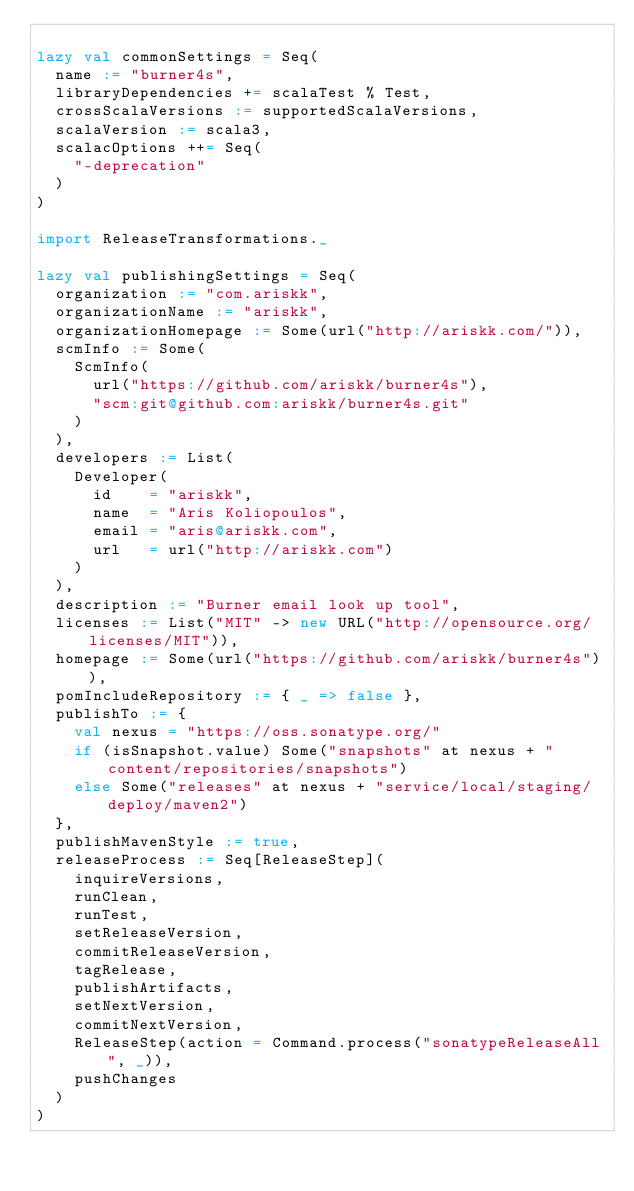<code> <loc_0><loc_0><loc_500><loc_500><_Scala_>
lazy val commonSettings = Seq(
  name := "burner4s",
  libraryDependencies += scalaTest % Test,
  crossScalaVersions := supportedScalaVersions,
  scalaVersion := scala3,
  scalacOptions ++= Seq(
    "-deprecation"
  )
)

import ReleaseTransformations._

lazy val publishingSettings = Seq(
  organization := "com.ariskk",
  organizationName := "ariskk",
  organizationHomepage := Some(url("http://ariskk.com/")),
  scmInfo := Some(
    ScmInfo(
      url("https://github.com/ariskk/burner4s"),
      "scm:git@github.com:ariskk/burner4s.git"
    )
  ),
  developers := List(
    Developer(
      id    = "ariskk",
      name  = "Aris Koliopoulos",
      email = "aris@ariskk.com",
      url   = url("http://ariskk.com")
    )
  ),
  description := "Burner email look up tool",
  licenses := List("MIT" -> new URL("http://opensource.org/licenses/MIT")),
  homepage := Some(url("https://github.com/ariskk/burner4s")),
  pomIncludeRepository := { _ => false },
  publishTo := {
    val nexus = "https://oss.sonatype.org/"
    if (isSnapshot.value) Some("snapshots" at nexus + "content/repositories/snapshots")
    else Some("releases" at nexus + "service/local/staging/deploy/maven2")
  },
  publishMavenStyle := true,
  releaseProcess := Seq[ReleaseStep](
    inquireVersions,
    runClean,
    runTest,
    setReleaseVersion,
    commitReleaseVersion,
    tagRelease,
    publishArtifacts,
    setNextVersion,
    commitNextVersion,
    ReleaseStep(action = Command.process("sonatypeReleaseAll", _)),
    pushChanges
  )
)
</code> 